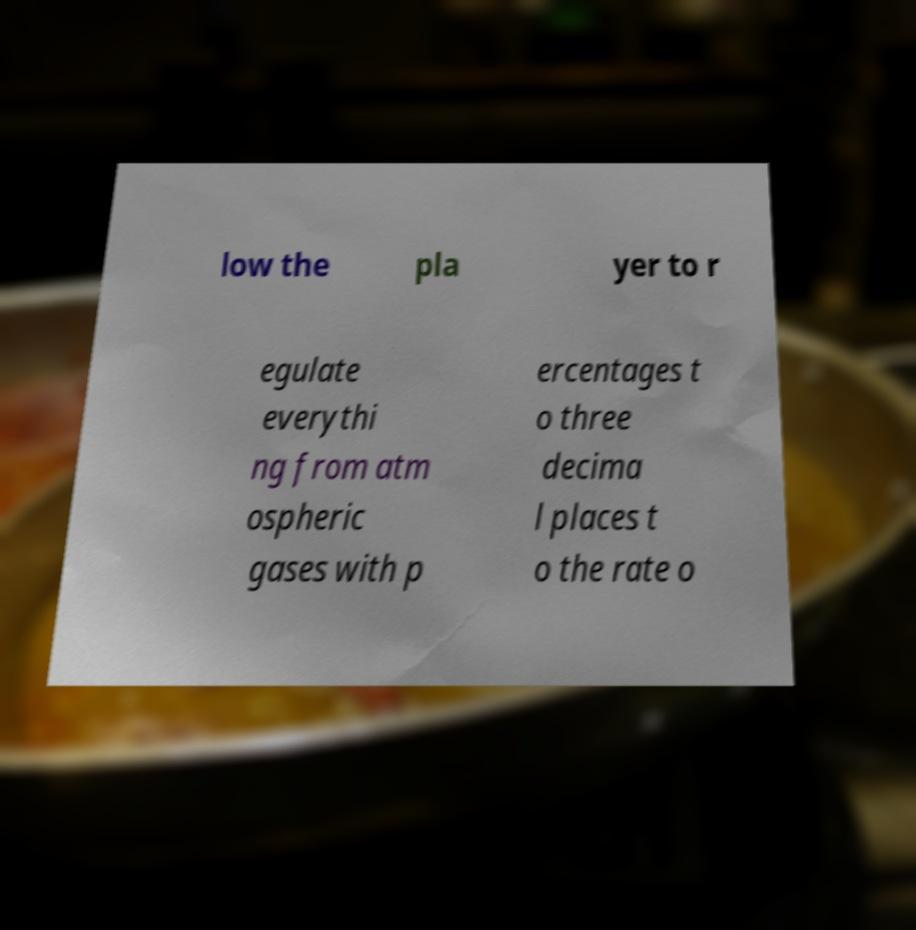Can you read and provide the text displayed in the image?This photo seems to have some interesting text. Can you extract and type it out for me? low the pla yer to r egulate everythi ng from atm ospheric gases with p ercentages t o three decima l places t o the rate o 